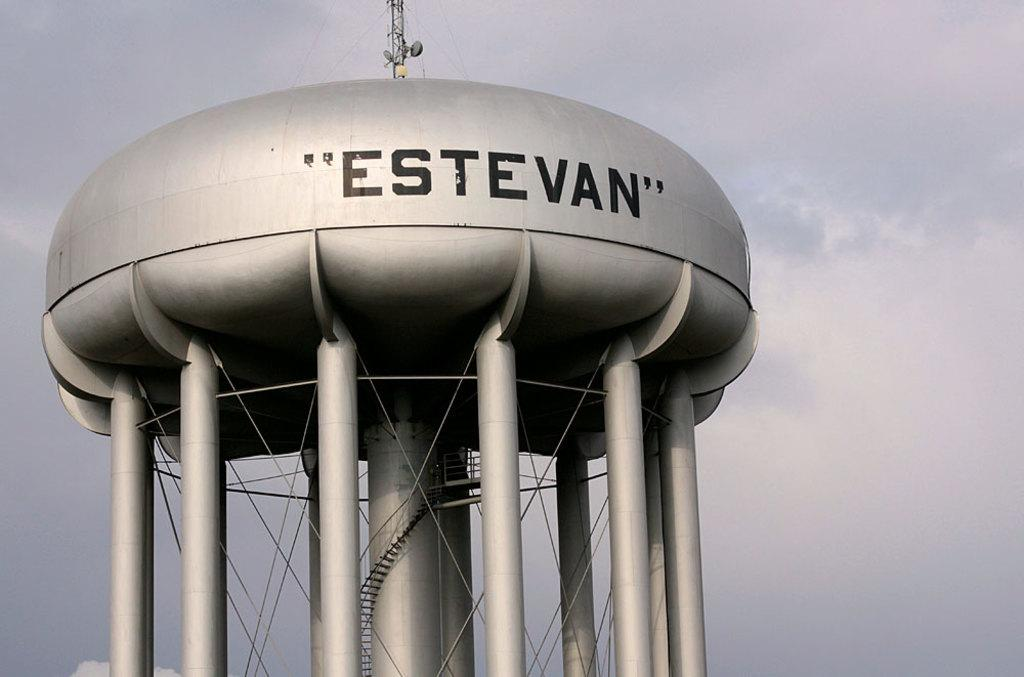<image>
Provide a brief description of the given image. a building that has the word Estevan on it 